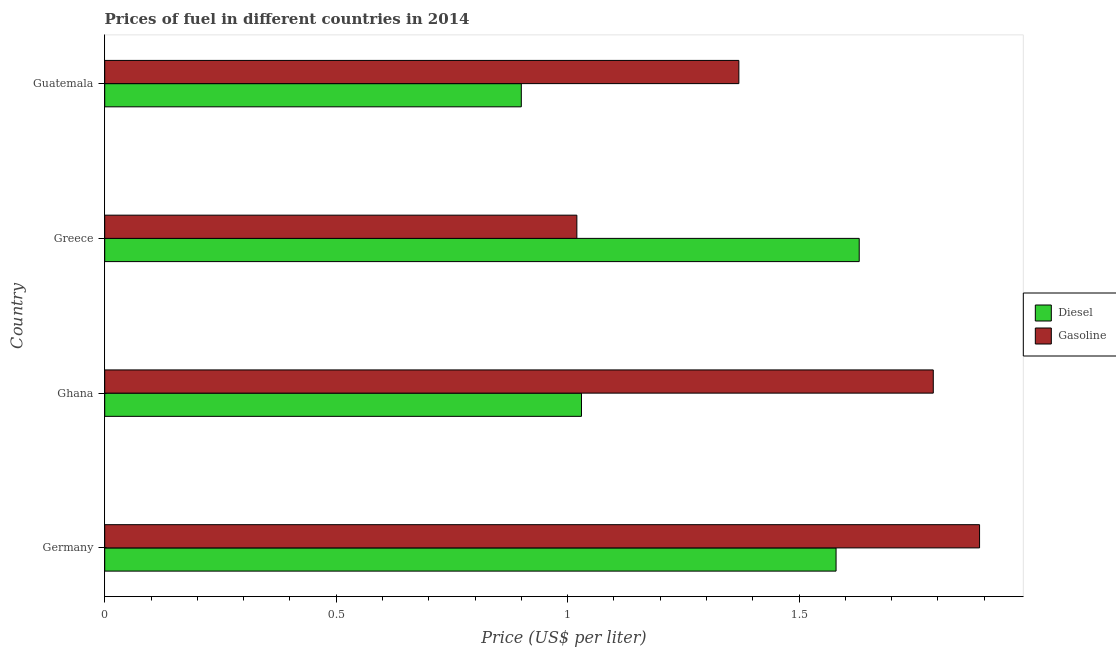How many different coloured bars are there?
Offer a terse response. 2. How many groups of bars are there?
Make the answer very short. 4. How many bars are there on the 4th tick from the top?
Offer a terse response. 2. What is the label of the 3rd group of bars from the top?
Your answer should be very brief. Ghana. In how many cases, is the number of bars for a given country not equal to the number of legend labels?
Ensure brevity in your answer.  0. What is the gasoline price in Germany?
Keep it short and to the point. 1.89. Across all countries, what is the maximum gasoline price?
Your answer should be compact. 1.89. In which country was the diesel price minimum?
Your answer should be compact. Guatemala. What is the total gasoline price in the graph?
Ensure brevity in your answer.  6.07. What is the difference between the gasoline price in Greece and that in Guatemala?
Give a very brief answer. -0.35. What is the difference between the gasoline price in Guatemala and the diesel price in Germany?
Keep it short and to the point. -0.21. What is the average gasoline price per country?
Offer a terse response. 1.52. What is the difference between the diesel price and gasoline price in Ghana?
Your answer should be very brief. -0.76. In how many countries, is the gasoline price greater than 0.6 US$ per litre?
Ensure brevity in your answer.  4. What is the ratio of the gasoline price in Germany to that in Ghana?
Keep it short and to the point. 1.06. What is the difference between the highest and the second highest gasoline price?
Offer a very short reply. 0.1. What is the difference between the highest and the lowest diesel price?
Keep it short and to the point. 0.73. What does the 1st bar from the top in Germany represents?
Ensure brevity in your answer.  Gasoline. What does the 2nd bar from the bottom in Germany represents?
Your response must be concise. Gasoline. How many countries are there in the graph?
Provide a short and direct response. 4. Does the graph contain any zero values?
Your answer should be compact. No. Does the graph contain grids?
Provide a succinct answer. No. How many legend labels are there?
Provide a succinct answer. 2. How are the legend labels stacked?
Give a very brief answer. Vertical. What is the title of the graph?
Offer a terse response. Prices of fuel in different countries in 2014. What is the label or title of the X-axis?
Give a very brief answer. Price (US$ per liter). What is the label or title of the Y-axis?
Provide a succinct answer. Country. What is the Price (US$ per liter) of Diesel in Germany?
Provide a succinct answer. 1.58. What is the Price (US$ per liter) in Gasoline in Germany?
Ensure brevity in your answer.  1.89. What is the Price (US$ per liter) in Diesel in Ghana?
Your answer should be compact. 1.03. What is the Price (US$ per liter) in Gasoline in Ghana?
Keep it short and to the point. 1.79. What is the Price (US$ per liter) of Diesel in Greece?
Provide a succinct answer. 1.63. What is the Price (US$ per liter) in Gasoline in Guatemala?
Provide a short and direct response. 1.37. Across all countries, what is the maximum Price (US$ per liter) in Diesel?
Make the answer very short. 1.63. Across all countries, what is the maximum Price (US$ per liter) of Gasoline?
Give a very brief answer. 1.89. Across all countries, what is the minimum Price (US$ per liter) of Diesel?
Give a very brief answer. 0.9. Across all countries, what is the minimum Price (US$ per liter) of Gasoline?
Your answer should be compact. 1.02. What is the total Price (US$ per liter) of Diesel in the graph?
Keep it short and to the point. 5.14. What is the total Price (US$ per liter) of Gasoline in the graph?
Your response must be concise. 6.07. What is the difference between the Price (US$ per liter) of Diesel in Germany and that in Ghana?
Offer a very short reply. 0.55. What is the difference between the Price (US$ per liter) in Gasoline in Germany and that in Ghana?
Your response must be concise. 0.1. What is the difference between the Price (US$ per liter) in Gasoline in Germany and that in Greece?
Provide a short and direct response. 0.87. What is the difference between the Price (US$ per liter) in Diesel in Germany and that in Guatemala?
Give a very brief answer. 0.68. What is the difference between the Price (US$ per liter) of Gasoline in Germany and that in Guatemala?
Your response must be concise. 0.52. What is the difference between the Price (US$ per liter) in Diesel in Ghana and that in Greece?
Ensure brevity in your answer.  -0.6. What is the difference between the Price (US$ per liter) in Gasoline in Ghana and that in Greece?
Ensure brevity in your answer.  0.77. What is the difference between the Price (US$ per liter) of Diesel in Ghana and that in Guatemala?
Provide a short and direct response. 0.13. What is the difference between the Price (US$ per liter) of Gasoline in Ghana and that in Guatemala?
Your answer should be compact. 0.42. What is the difference between the Price (US$ per liter) in Diesel in Greece and that in Guatemala?
Offer a very short reply. 0.73. What is the difference between the Price (US$ per liter) of Gasoline in Greece and that in Guatemala?
Offer a terse response. -0.35. What is the difference between the Price (US$ per liter) of Diesel in Germany and the Price (US$ per liter) of Gasoline in Ghana?
Ensure brevity in your answer.  -0.21. What is the difference between the Price (US$ per liter) of Diesel in Germany and the Price (US$ per liter) of Gasoline in Greece?
Your response must be concise. 0.56. What is the difference between the Price (US$ per liter) in Diesel in Germany and the Price (US$ per liter) in Gasoline in Guatemala?
Offer a terse response. 0.21. What is the difference between the Price (US$ per liter) of Diesel in Ghana and the Price (US$ per liter) of Gasoline in Guatemala?
Your response must be concise. -0.34. What is the difference between the Price (US$ per liter) in Diesel in Greece and the Price (US$ per liter) in Gasoline in Guatemala?
Offer a terse response. 0.26. What is the average Price (US$ per liter) of Diesel per country?
Provide a succinct answer. 1.28. What is the average Price (US$ per liter) in Gasoline per country?
Offer a terse response. 1.52. What is the difference between the Price (US$ per liter) in Diesel and Price (US$ per liter) in Gasoline in Germany?
Your answer should be compact. -0.31. What is the difference between the Price (US$ per liter) of Diesel and Price (US$ per liter) of Gasoline in Ghana?
Make the answer very short. -0.76. What is the difference between the Price (US$ per liter) in Diesel and Price (US$ per liter) in Gasoline in Greece?
Ensure brevity in your answer.  0.61. What is the difference between the Price (US$ per liter) of Diesel and Price (US$ per liter) of Gasoline in Guatemala?
Ensure brevity in your answer.  -0.47. What is the ratio of the Price (US$ per liter) of Diesel in Germany to that in Ghana?
Offer a very short reply. 1.53. What is the ratio of the Price (US$ per liter) in Gasoline in Germany to that in Ghana?
Your answer should be compact. 1.06. What is the ratio of the Price (US$ per liter) in Diesel in Germany to that in Greece?
Provide a short and direct response. 0.97. What is the ratio of the Price (US$ per liter) in Gasoline in Germany to that in Greece?
Provide a short and direct response. 1.85. What is the ratio of the Price (US$ per liter) of Diesel in Germany to that in Guatemala?
Your response must be concise. 1.76. What is the ratio of the Price (US$ per liter) in Gasoline in Germany to that in Guatemala?
Your answer should be compact. 1.38. What is the ratio of the Price (US$ per liter) in Diesel in Ghana to that in Greece?
Provide a short and direct response. 0.63. What is the ratio of the Price (US$ per liter) of Gasoline in Ghana to that in Greece?
Your answer should be very brief. 1.75. What is the ratio of the Price (US$ per liter) in Diesel in Ghana to that in Guatemala?
Your response must be concise. 1.14. What is the ratio of the Price (US$ per liter) of Gasoline in Ghana to that in Guatemala?
Make the answer very short. 1.31. What is the ratio of the Price (US$ per liter) of Diesel in Greece to that in Guatemala?
Provide a succinct answer. 1.81. What is the ratio of the Price (US$ per liter) in Gasoline in Greece to that in Guatemala?
Provide a short and direct response. 0.74. What is the difference between the highest and the second highest Price (US$ per liter) of Diesel?
Your answer should be very brief. 0.05. What is the difference between the highest and the lowest Price (US$ per liter) of Diesel?
Your answer should be very brief. 0.73. What is the difference between the highest and the lowest Price (US$ per liter) in Gasoline?
Your answer should be very brief. 0.87. 